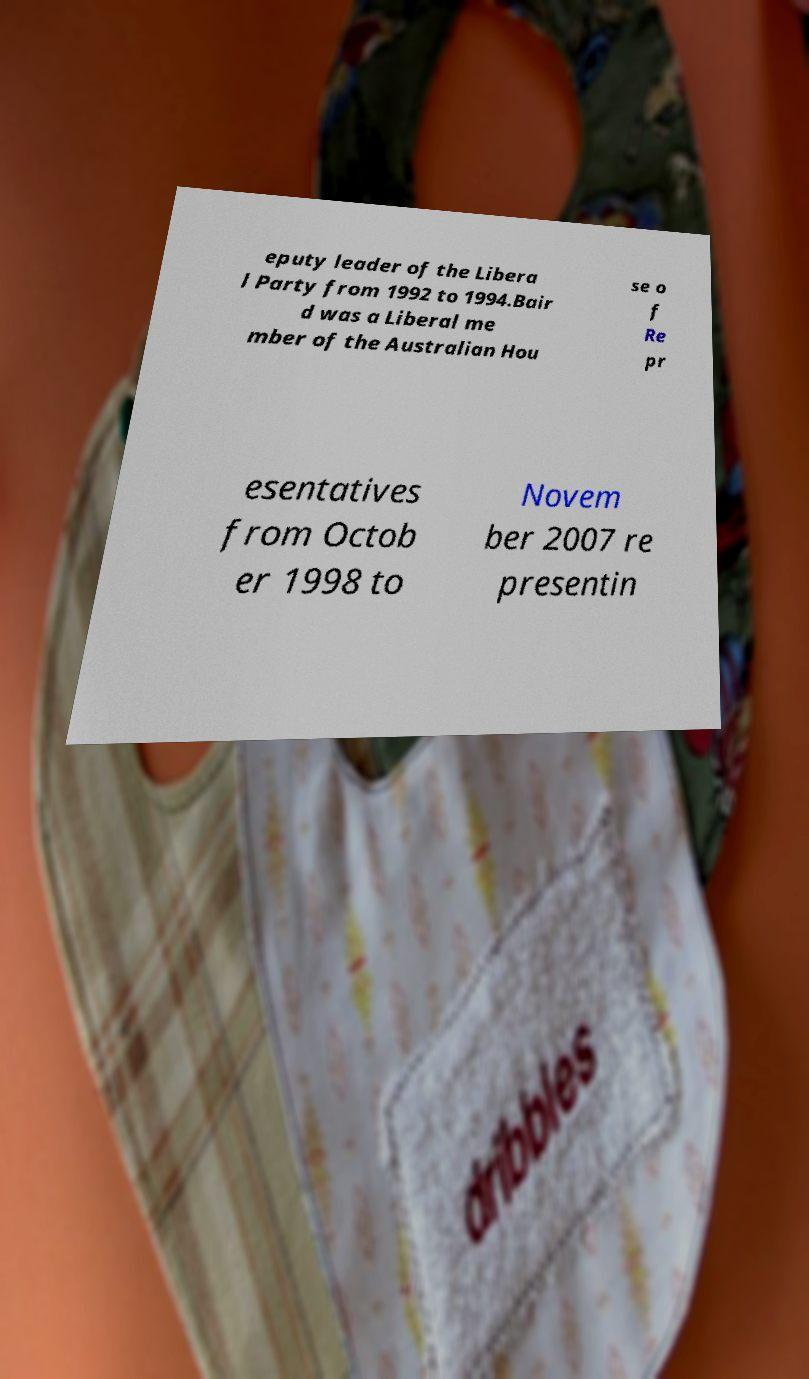Please read and relay the text visible in this image. What does it say? eputy leader of the Libera l Party from 1992 to 1994.Bair d was a Liberal me mber of the Australian Hou se o f Re pr esentatives from Octob er 1998 to Novem ber 2007 re presentin 